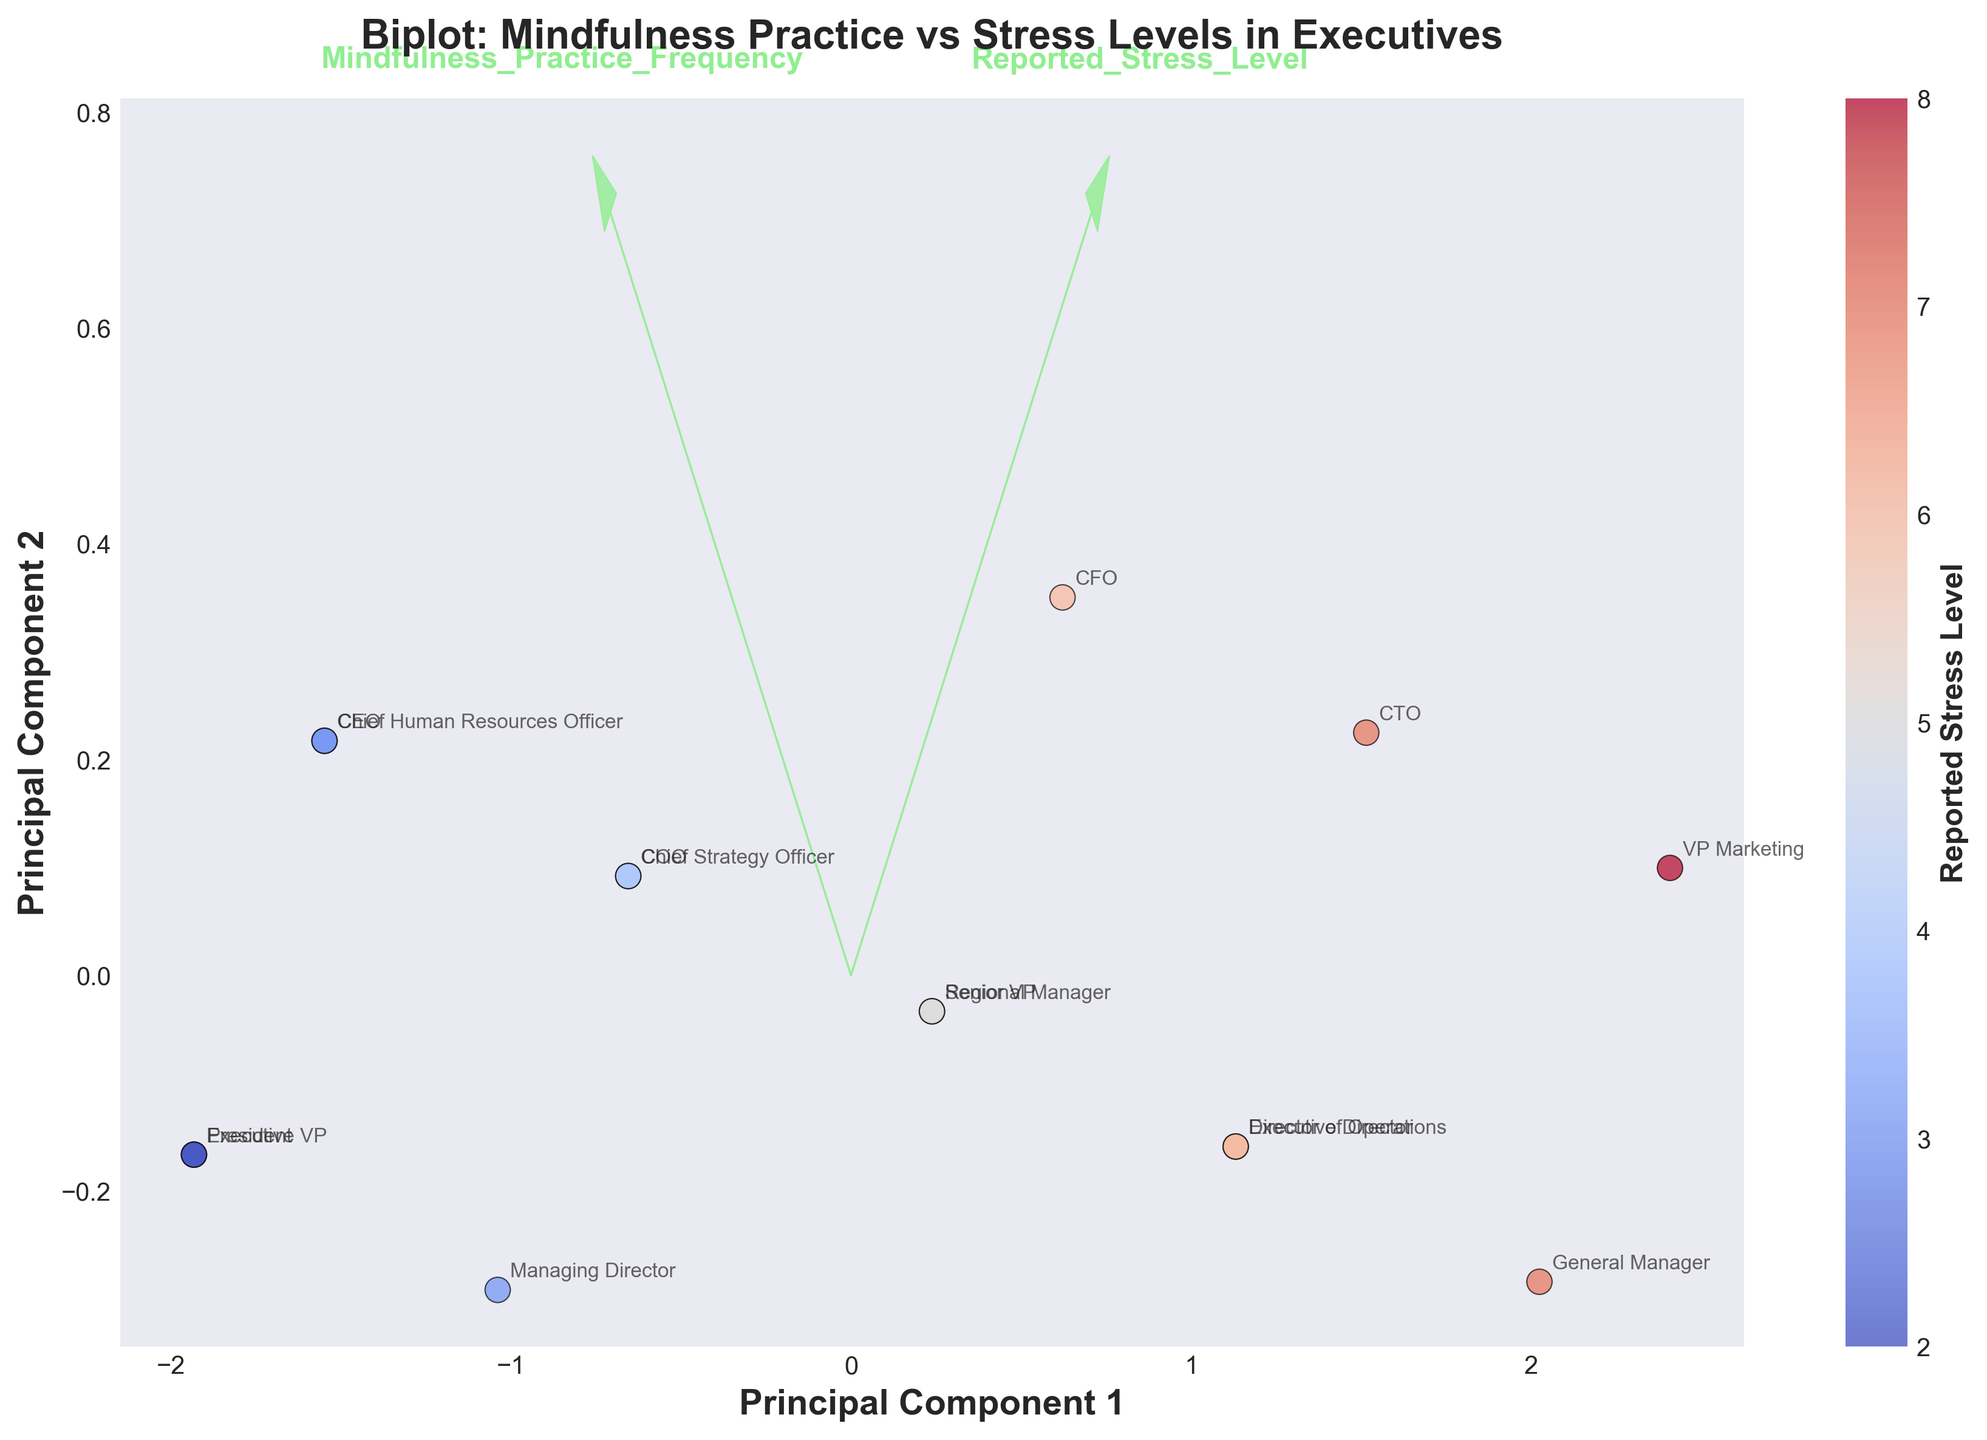What is the title of the plot? The title is generally located at the top of the figure and explicitly states the main subject of the visualization. By looking at the top center, it reads, "Biplot: Mindfulness Practice vs Stress Levels in Executives".
Answer: Biplot: Mindfulness Practice vs Stress Levels in Executives How many executives are represented in the biplot? Each data point represents an executive's Job Title and is annotated in the plot. By counting these annotations, we see that there are 15 data points (executives).
Answer: 15 What is the coloring scheme based on in the plot? The color of the data points ranges from cool to warm colors according to the color map 'coolwarm'. The color bar on the side indicates that the coloring scheme represents 'Reported Stress Level'.
Answer: Reported Stress Level Which Job Title is associated with the highest reported stress level? Each Job Title is annotated next to the corresponding data point. By looking at the scale bar for the highest stress level (deep red), the data point labeled "VP Marketing" has the stress level of 8, the highest reported in the plot.
Answer: VP Marketing Which Job Title practiced mindfulness the least? Mindfulness Practice Frequency is one of the features shown by the arrows in the biplot. By checking the 'Mindfulness_Practice_Frequency' dimension for the lowest value, data points closest to (i.e., with lower component in the direction of the arrow) the lowest frequency have titles like "VP Marketing" and "General Manager", both noted with 'Mindfulness Practice Frequency' as 1.
Answer: VP Marketing and General Manager How are Mindfulness Practice Frequency and Reported Stress Level generally related? The overall trend can be observed by looking at the spread and annotations of data points. Higher 'Mindfulness Practice Frequency' (towards the right arrow component) generally corresponds with lower 'Reported Stress Level' (cooler colors).
Answer: Generally inversely related Which executive title appears closest to the origin of the biplot? The origin of the biplot is the point (0,0). The Job Title nearest to this coordinate, based on their principal components, is "President".
Answer: President Compare the mindfulness practice frequency between "CEO" and "Executive VP". The Job Titles are annotated near their respective data points. Both "CEO" and "Executive VP" have a mindfulness practice frequency of 5, but located at different reported stress levels.
Answer: Both have a frequency of 5 Which industry has an executive with a stress level of 2? By interpreting the color bar and annotation for the stress level of 2 (deep blue color), the plot shows that both "President" and "Executive VP" of the Manufacturing and Telecommunications industries have this stress level.
Answer: Manufacturing and Telecommunications 